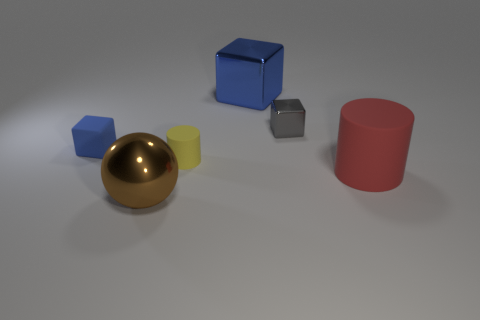How many cylinders are to the left of the small blue matte thing?
Provide a short and direct response. 0. What is the color of the small matte object in front of the tiny blue rubber thing?
Your answer should be very brief. Yellow. There is another rubber thing that is the same shape as the red rubber object; what color is it?
Make the answer very short. Yellow. Are there any other things of the same color as the large rubber thing?
Provide a succinct answer. No. Are there more big cyan shiny things than gray objects?
Keep it short and to the point. No. Are the big sphere and the yellow cylinder made of the same material?
Provide a short and direct response. No. How many tiny blue things are made of the same material as the big blue cube?
Your answer should be compact. 0. Is the size of the gray block the same as the shiny thing in front of the red rubber cylinder?
Your response must be concise. No. What color is the object that is left of the yellow cylinder and behind the red cylinder?
Your response must be concise. Blue. There is a rubber object that is to the right of the tiny yellow matte thing; are there any matte cubes in front of it?
Your response must be concise. No. 